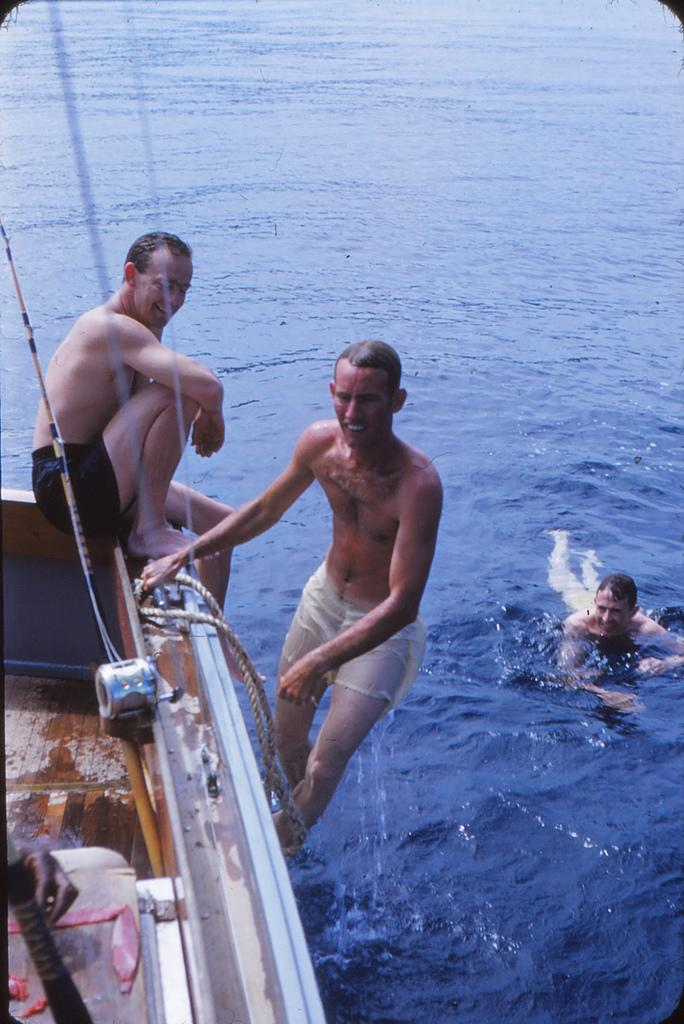What is the main subject of the image? The main subject of the image is a boat. Where is the boat located in the image? The boat is on the left side of the image. How many people are on the boat? There are two men on the boat. What is visible in the background of the image? There is water visible in the image. What else can be seen in the water? There is a man in the water on the right side of the image. What type of cub is playing with the man's shirt in the image? There is no cub or shirt present in the image. 